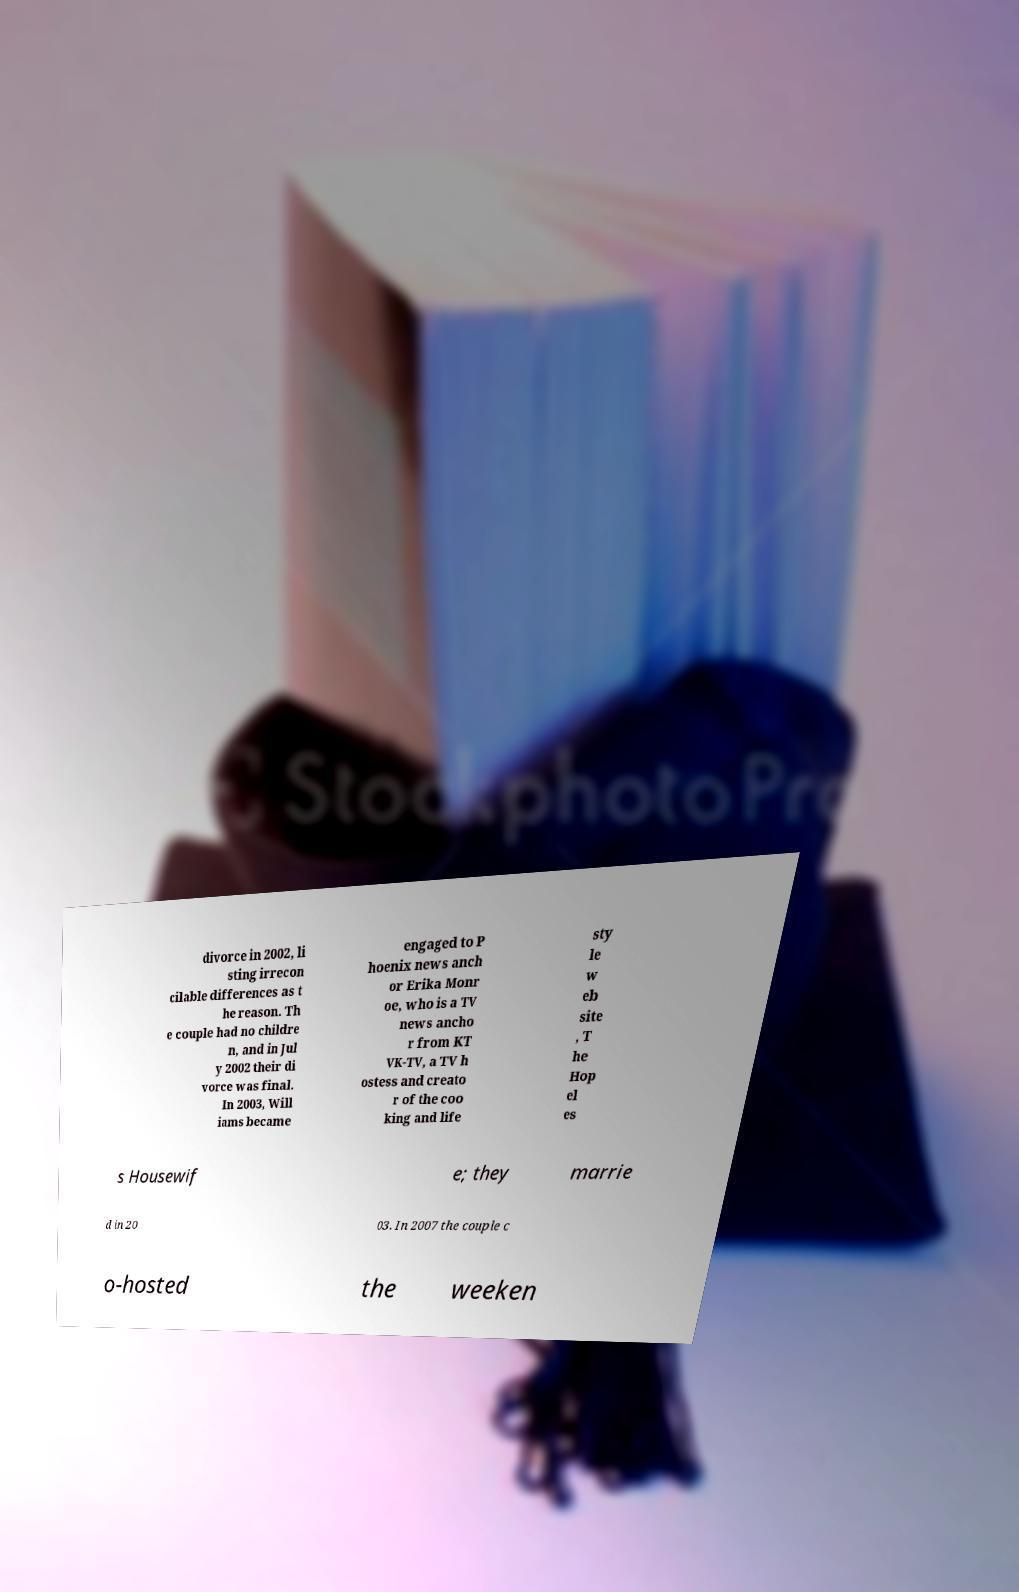Could you extract and type out the text from this image? divorce in 2002, li sting irrecon cilable differences as t he reason. Th e couple had no childre n, and in Jul y 2002 their di vorce was final. In 2003, Will iams became engaged to P hoenix news anch or Erika Monr oe, who is a TV news ancho r from KT VK-TV, a TV h ostess and creato r of the coo king and life sty le w eb site , T he Hop el es s Housewif e; they marrie d in 20 03. In 2007 the couple c o-hosted the weeken 